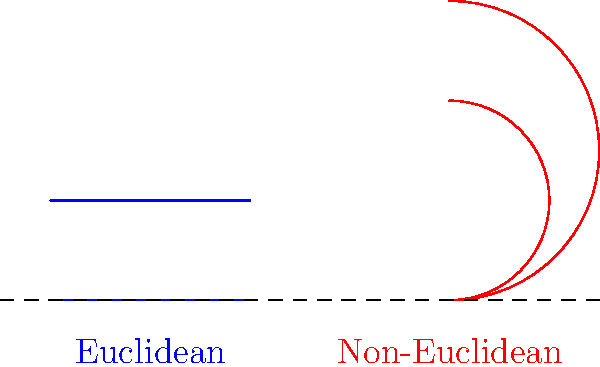In the context of parallel lines, analyze the differences between Euclidean and non-Euclidean geometries as depicted in the diagram. How might these distinctions impact the study of linguistic patterns in archaic European texts that reference geometric concepts? 1. Euclidean geometry (blue lines):
   - Parallel lines remain equidistant and never intersect.
   - They follow the fifth postulate of Euclid.

2. Non-Euclidean geometry (red curves):
   - Parallel lines can converge or diverge.
   - They violate Euclid's fifth postulate.

3. Linguistic implications:
   - Archaic texts may use geometric metaphors based on Euclidean concepts.
   - Non-Euclidean ideas might be absent or misunderstood in older writings.

4. Potential impacts on linguistic analysis:
   - Metaphors involving parallelism might have different interpretations.
   - Spatial relationships described in texts could be misinterpreted if assumed Euclidean.

5. Historical context:
   - Non-Euclidean geometry was developed much later (19th century).
   - Earlier texts would likely reflect Euclidean understanding only.

6. Translation considerations:
   - Modern translations of archaic texts might need to account for geometrical understanding of the time.
   - Explanatory notes might be necessary to clarify geometric concepts for modern readers.

7. Etymological analysis:
   - Terms for "parallel" or "equidistant" might have evolved with geometric understanding.
   - Tracing the evolution of such terms could provide insights into the development of mathematical thought in different cultures.
Answer: Euclidean parallels remain equidistant; non-Euclidean can converge/diverge. This distinction may affect interpretation of geometric metaphors and spatial concepts in archaic European texts. 